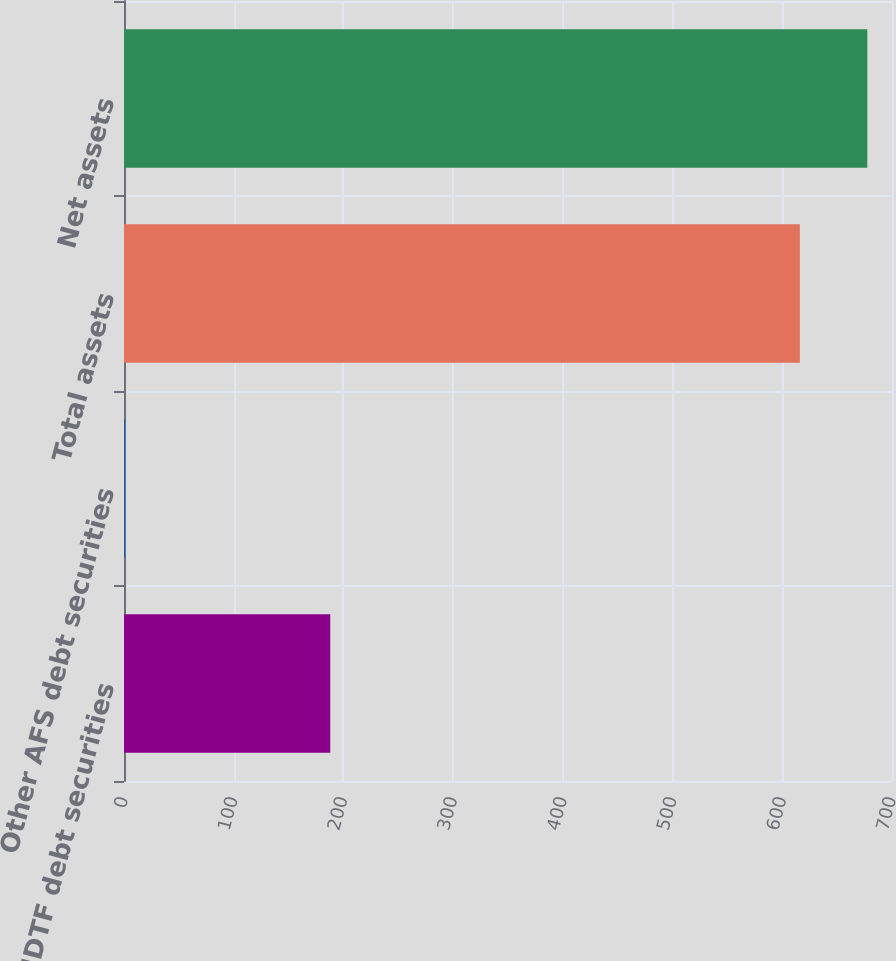<chart> <loc_0><loc_0><loc_500><loc_500><bar_chart><fcel>NDTF debt securities<fcel>Other AFS debt securities<fcel>Total assets<fcel>Net assets<nl><fcel>188<fcel>1<fcel>616<fcel>677.5<nl></chart> 